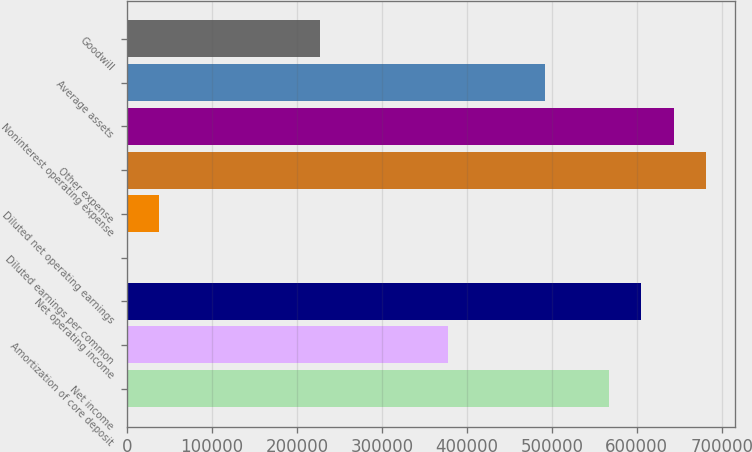<chart> <loc_0><loc_0><loc_500><loc_500><bar_chart><fcel>Net income<fcel>Amortization of core deposit<fcel>Net operating income<fcel>Diluted earnings per common<fcel>Diluted net operating earnings<fcel>Other expense<fcel>Noninterest operating expense<fcel>Average assets<fcel>Goodwill<nl><fcel>567532<fcel>378355<fcel>605367<fcel>1.35<fcel>37836.7<fcel>681038<fcel>643203<fcel>491861<fcel>227014<nl></chart> 